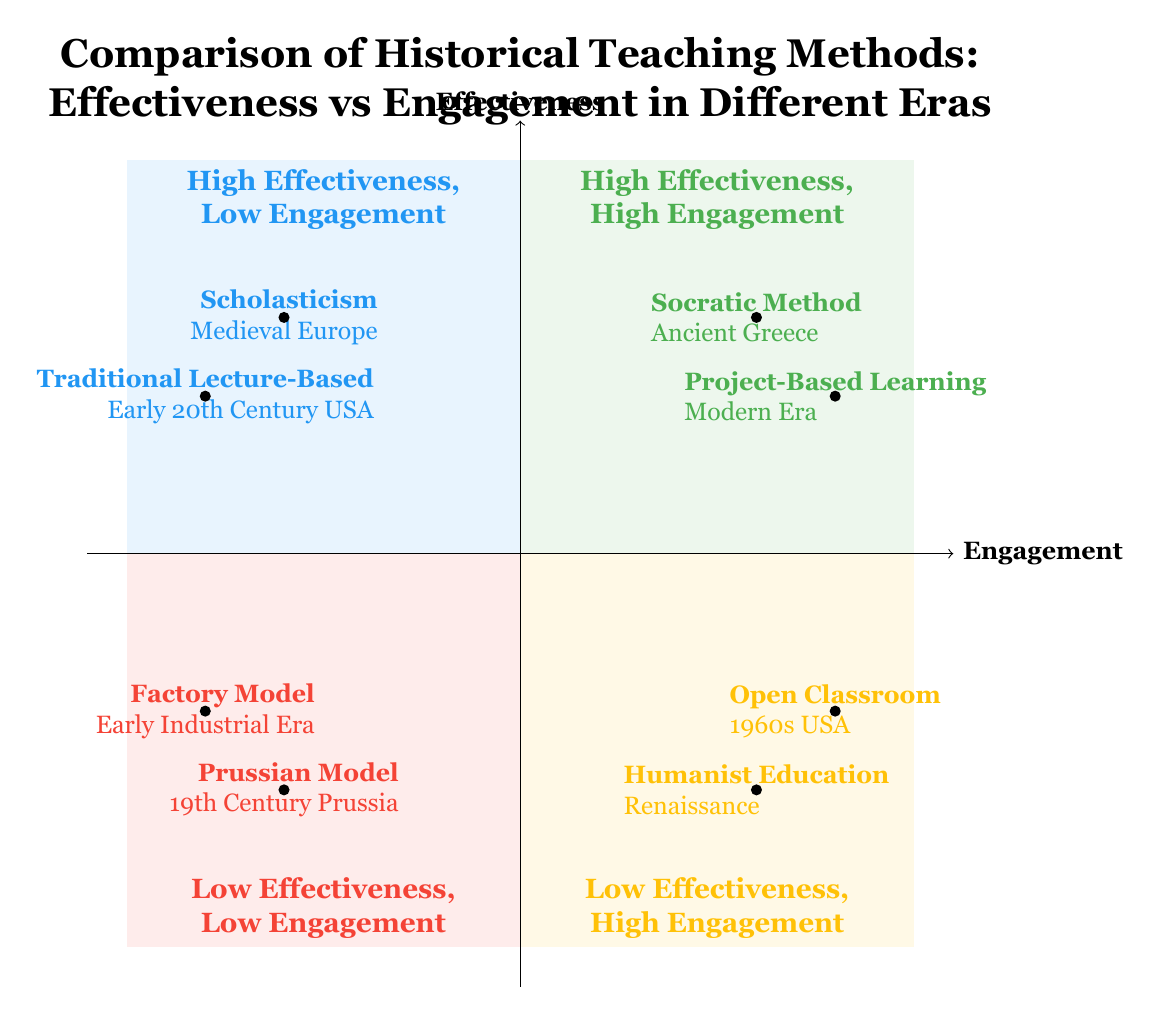What teaching method from Ancient Greece is located in the quadrant of High Effectiveness, High Engagement? The diagram shows the "Socratic Method" positioned in the High Effectiveness, High Engagement quadrant, which specifically indicates its effectiveness and engagement level.
Answer: Socratic Method How many teaching methods are located in the Low Effectiveness, Low Engagement quadrant? By examining the diagram, it is evident that there are two teaching methods shown in the Low Effectiveness, Low Engagement quadrant: "Prussian Model" and "Factory Model."
Answer: 2 Which method from the Renaissance period is situated in the Low Effectiveness, High Engagement quadrant? The diagram indicates that "Humanist Education" is the method corresponding to the Renaissance period placed in the Low Effectiveness, High Engagement quadrant.
Answer: Humanist Education What is the primary axis representing Effectiveness labeled as? The diagram clearly labels the vertical axis as "Effectiveness," indicating what is being measured on that axis.
Answer: Effectiveness Which method listed in the High Effectiveness, Low Engagement quadrant emphasizes understanding of religious texts? The diagram shows that "Scholasticism," found in the High Effectiveness, Low Engagement quadrant, emphasizes a rigorous understanding of religious texts.
Answer: Scholasticism What teaching method was characteristic of the 1960s USA, and in which quadrant is it located? According to the diagram, the "Open Classroom" method, which is characteristic of the 1960s USA, is placed in the Low Effectiveness, High Engagement quadrant.
Answer: Open Classroom Which quadrant contains methods with both low effectiveness and low engagement? The diagram identifies the Low Effectiveness, Low Engagement quadrant, where methods like "Prussian Model" and "Factory Model" are located together.
Answer: Low Effectiveness, Low Engagement What educational approach is associated with students-centered inquiries in the Modern Era? The diagram indicates that "Project-Based Learning" is the approach associated with student-centered inquiries in the Modern Era, located in the High Effectiveness, High Engagement quadrant.
Answer: Project-Based Learning 